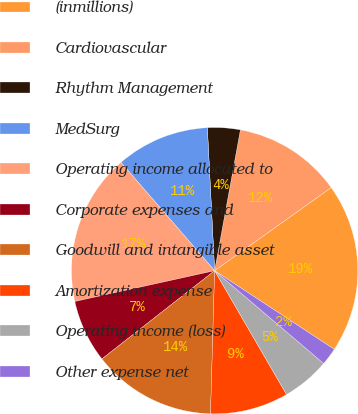Convert chart. <chart><loc_0><loc_0><loc_500><loc_500><pie_chart><fcel>(inmillions)<fcel>Cardiovascular<fcel>Rhythm Management<fcel>MedSurg<fcel>Operating income allocated to<fcel>Corporate expenses and<fcel>Goodwill and intangible asset<fcel>Amortization expense<fcel>Operating income (loss)<fcel>Other expense net<nl><fcel>19.11%<fcel>12.26%<fcel>3.69%<fcel>10.54%<fcel>17.1%<fcel>7.12%<fcel>13.97%<fcel>8.83%<fcel>5.4%<fcel>1.97%<nl></chart> 